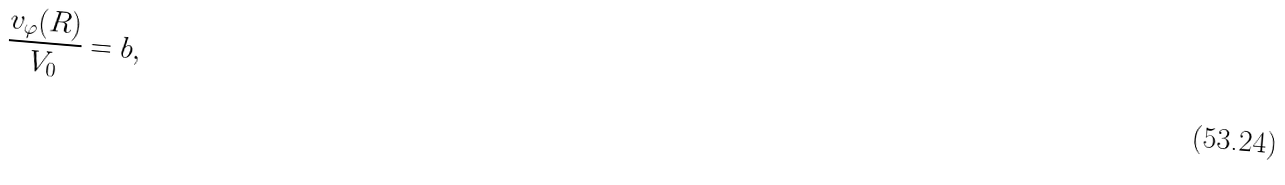<formula> <loc_0><loc_0><loc_500><loc_500>\frac { v _ { \varphi } ( R ) } { V _ { 0 } } = b ,</formula> 